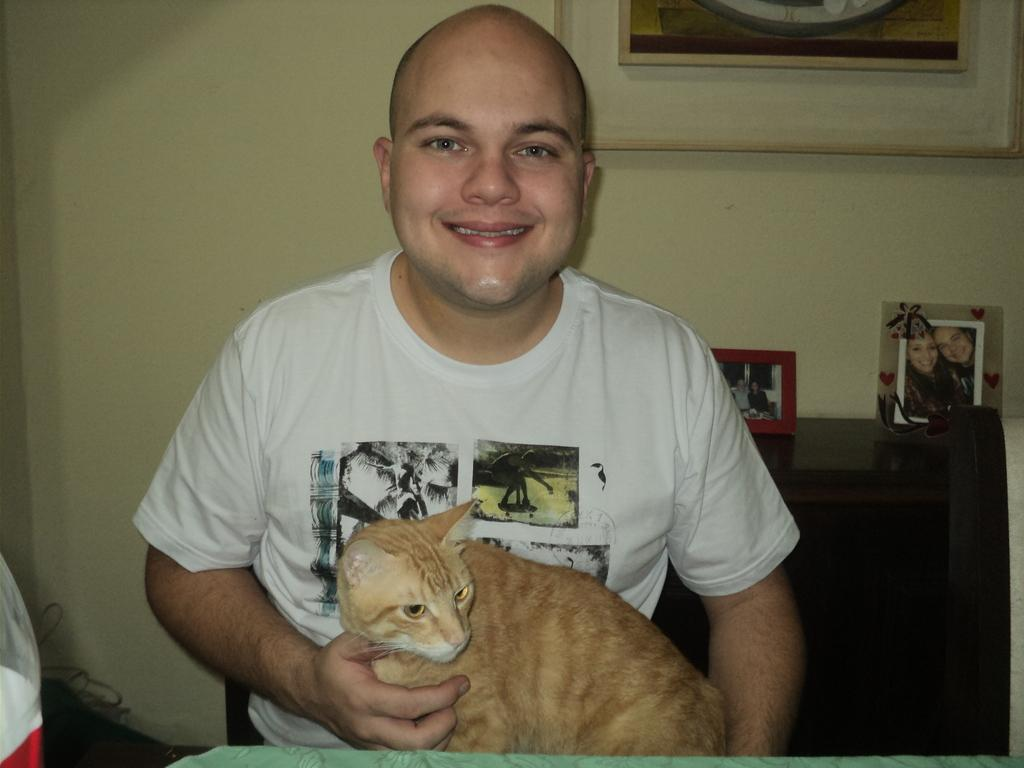Who is present in the image? There is a man in the image. What is the man doing in the image? The man is smiling and holding a cat in his hands. What can be seen in the background of the image? There is a wall and photo frames in the background of the image. What theory does the man propose in the image? There is no indication in the image that the man is proposing a theory. Can you touch the cat in the image? You cannot touch the cat in the image, as it is a two-dimensional representation. 